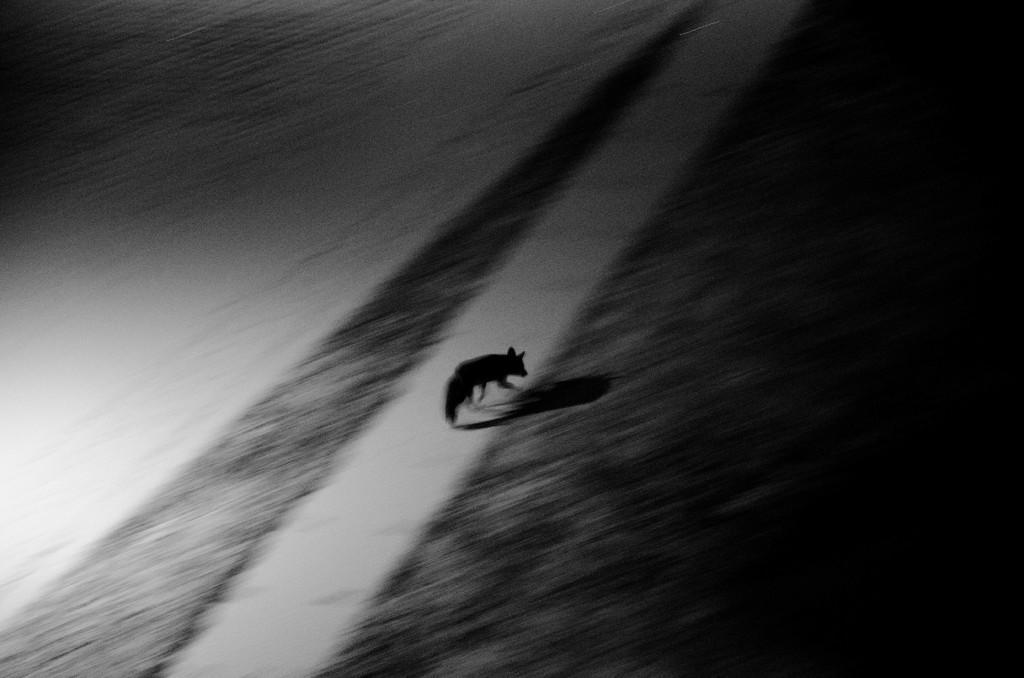Could you give a brief overview of what you see in this image? This is a black and white image. In the image we can see an animal on the ground. 